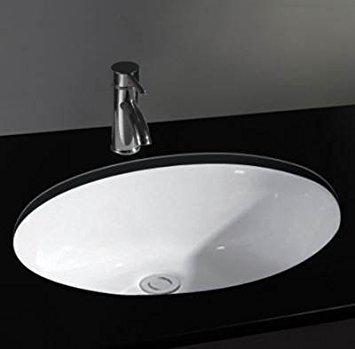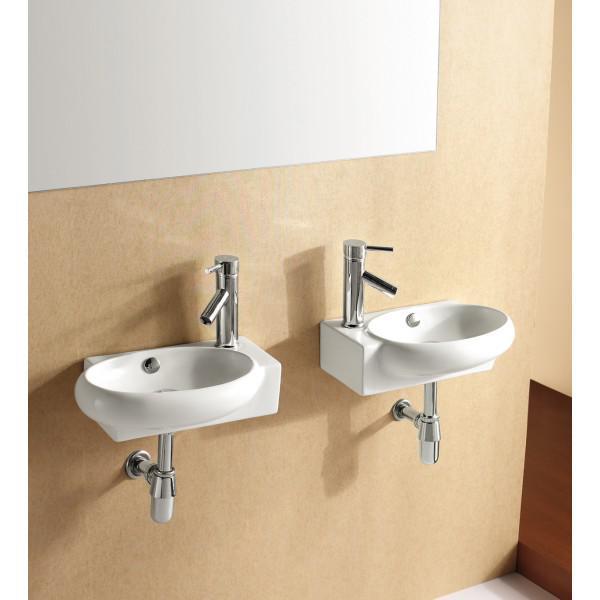The first image is the image on the left, the second image is the image on the right. Examine the images to the left and right. Is the description "The sink on the left is a circular shape with a white interior" accurate? Answer yes or no. Yes. The first image is the image on the left, the second image is the image on the right. Given the left and right images, does the statement "One sink has a round basin and features a two-tone design that includes a bright color." hold true? Answer yes or no. No. 